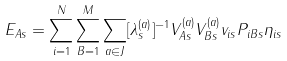Convert formula to latex. <formula><loc_0><loc_0><loc_500><loc_500>E _ { A s } = \sum _ { i = 1 } ^ { N } \sum _ { B = 1 } ^ { M } \sum _ { a \in J } [ \lambda ^ { ( a ) } _ { s } ] ^ { - 1 } V ^ { ( a ) } _ { A s } V ^ { ( a ) } _ { B s } v _ { i s } P _ { i B s } \eta _ { i s }</formula> 